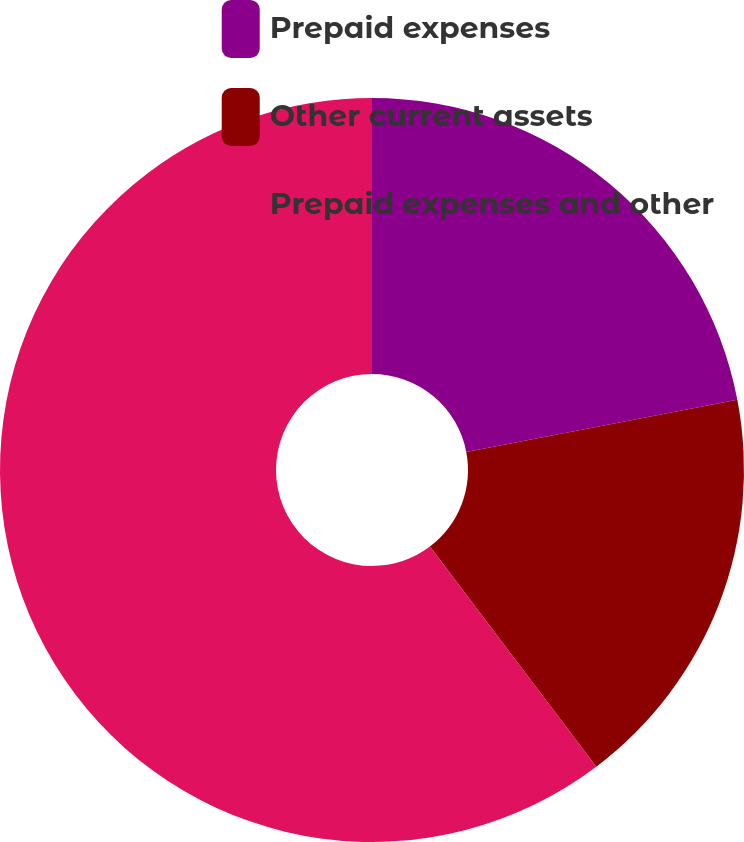Convert chart to OTSL. <chart><loc_0><loc_0><loc_500><loc_500><pie_chart><fcel>Prepaid expenses<fcel>Other current assets<fcel>Prepaid expenses and other<nl><fcel>21.98%<fcel>17.72%<fcel>60.3%<nl></chart> 